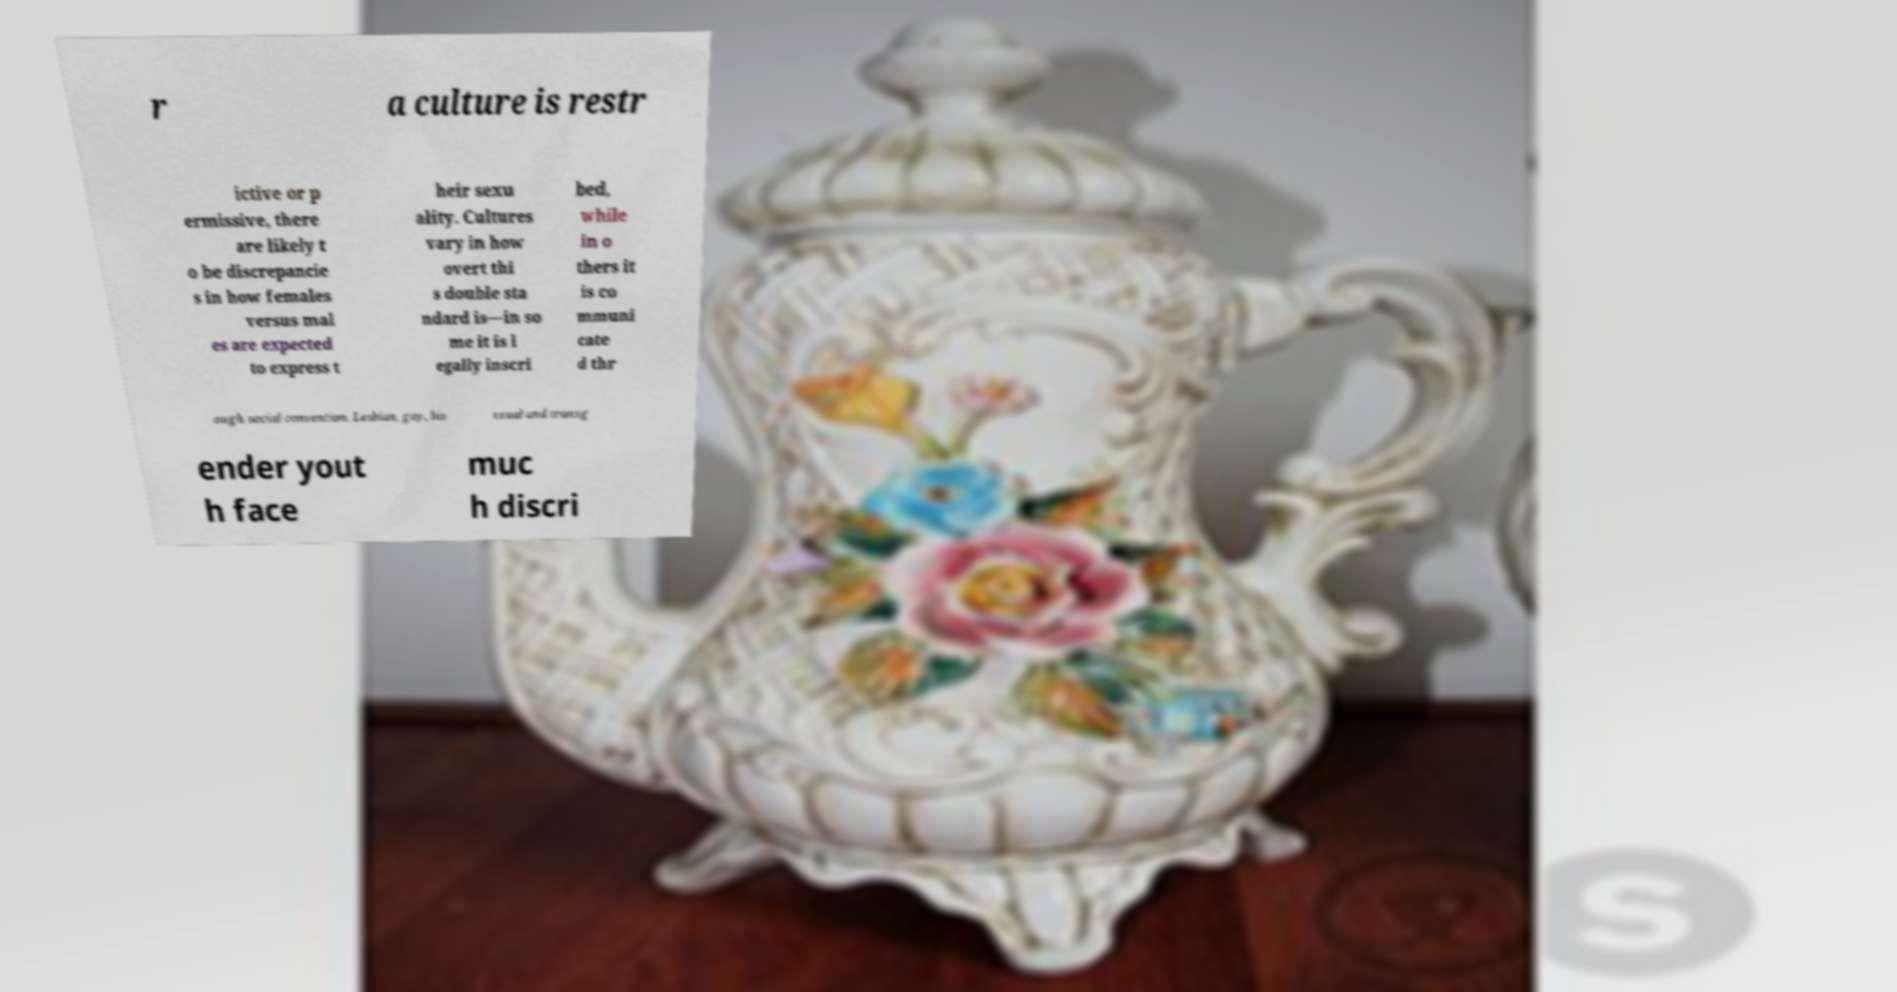There's text embedded in this image that I need extracted. Can you transcribe it verbatim? r a culture is restr ictive or p ermissive, there are likely t o be discrepancie s in how females versus mal es are expected to express t heir sexu ality. Cultures vary in how overt thi s double sta ndard is—in so me it is l egally inscri bed, while in o thers it is co mmuni cate d thr ough social convention. Lesbian, gay, bis exual and transg ender yout h face muc h discri 